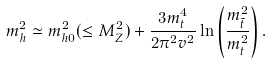<formula> <loc_0><loc_0><loc_500><loc_500>m _ { h } ^ { 2 } \simeq m _ { h 0 } ^ { 2 } ( \leq M _ { Z } ^ { 2 } ) + \frac { 3 m _ { t } ^ { 4 } } { 2 \pi ^ { 2 } v ^ { 2 } } \ln \left ( \frac { m ^ { 2 } _ { \tilde { t } } } { m _ { t } ^ { 2 } } \right ) .</formula> 